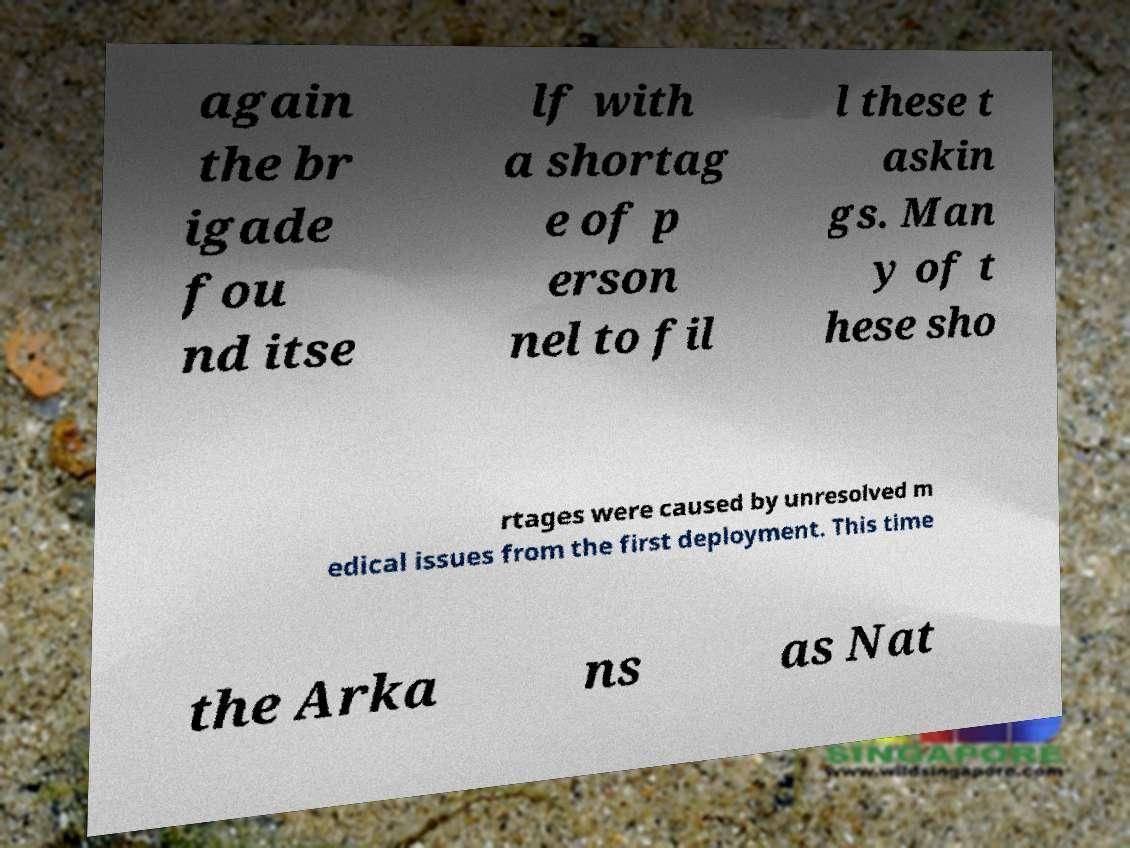Please read and relay the text visible in this image. What does it say? again the br igade fou nd itse lf with a shortag e of p erson nel to fil l these t askin gs. Man y of t hese sho rtages were caused by unresolved m edical issues from the first deployment. This time the Arka ns as Nat 